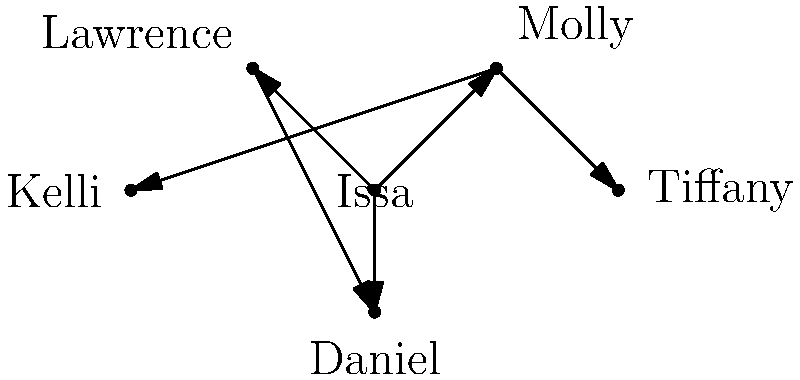Based on the network graph representing character relationships in 'Insecure', which character has the highest degree centrality (i.e., the most direct connections to other characters)? To determine the character with the highest degree centrality, we need to count the number of direct connections (edges) for each character in the network graph:

1. Issa: Connected to Molly, Lawrence, and Daniel (3 connections)
2. Molly: Connected to Issa, Tiffany, and Kelli (3 connections)
3. Lawrence: Connected to Issa and Daniel (2 connections)
4. Daniel: Connected to Issa and Lawrence (2 connections)
5. Tiffany: Connected to Molly (1 connection)
6. Kelli: Connected to Molly (1 connection)

Both Issa and Molly have the highest number of direct connections with 3 each. However, Issa's connections span a wider range of characters (including both her romantic interests and her best friend), making her central to more diverse storylines.
Answer: Issa 